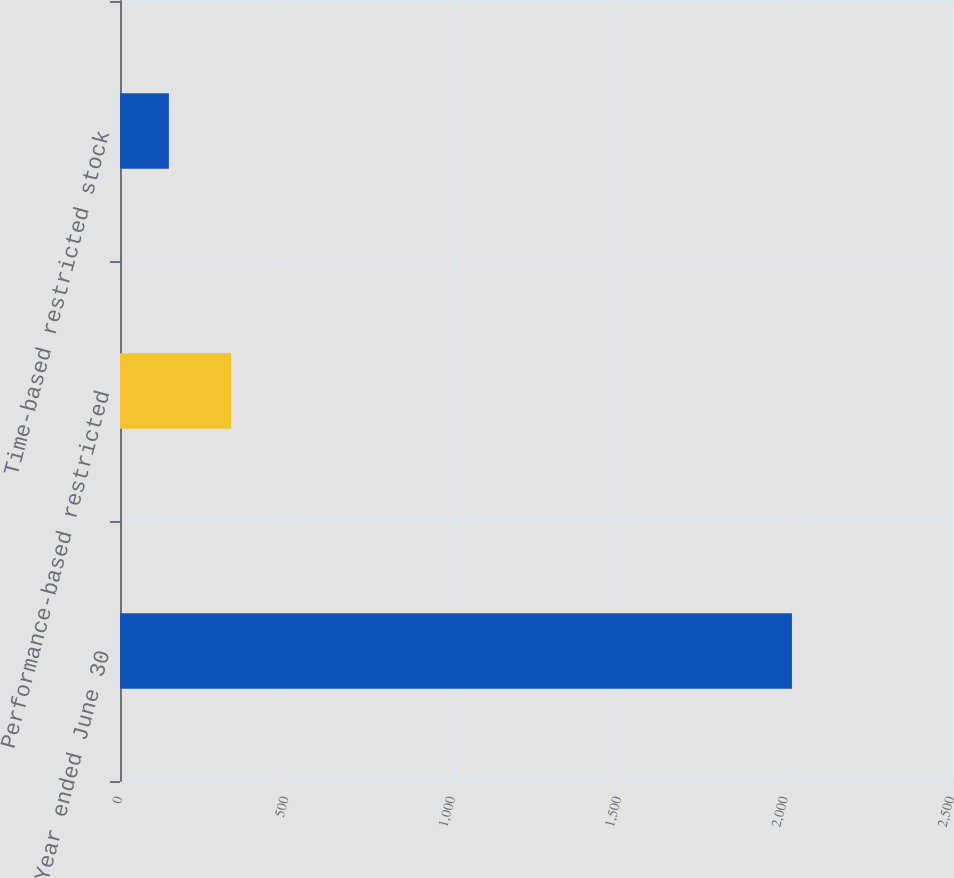<chart> <loc_0><loc_0><loc_500><loc_500><bar_chart><fcel>Year ended June 30<fcel>Performance-based restricted<fcel>Time-based restricted stock<nl><fcel>2019<fcel>334.02<fcel>146.8<nl></chart> 